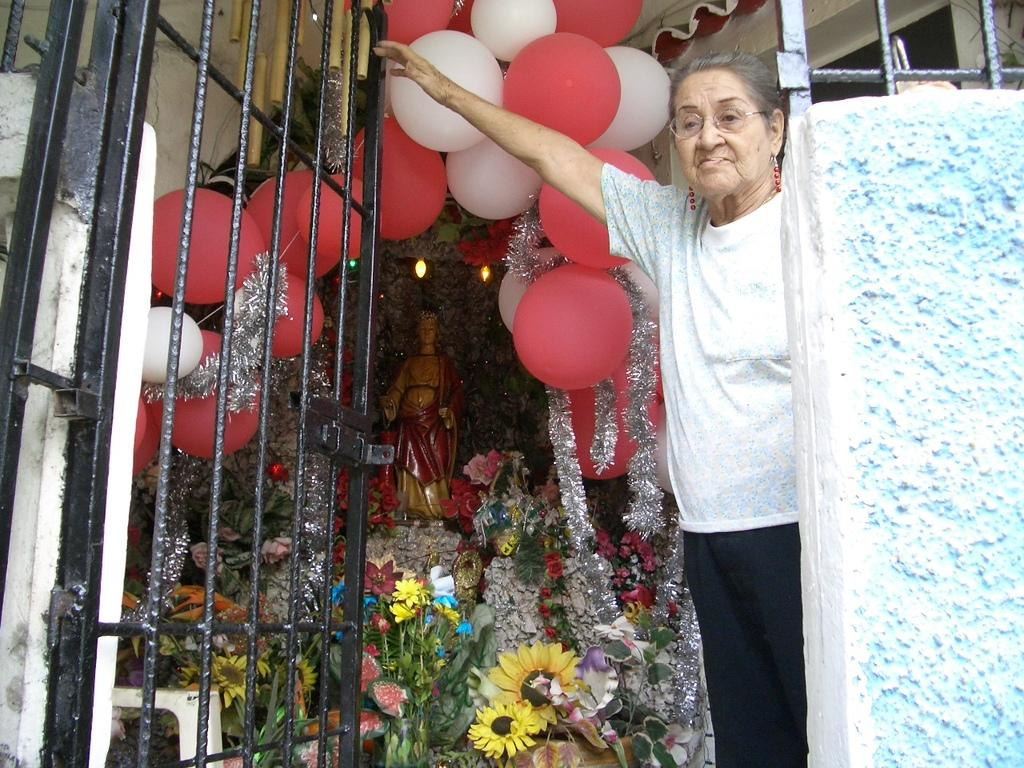What is located in the front of the image? There is a grille, rods, a woman, and a wall in the front of the image. What can be seen in the background of the image? There are balloons, flowers, a statue, lights, and decorative things in the background of the image. How many objects can be identified in the background of the image? There are at least ten objects in the background of the image, including balloons, flowers, a statue, lights, and decorative things. What type of van is parked on the roof in the image? There is no van or roof present in the image. Who is the porter in the image? There is no porter mentioned or depicted in the image. 